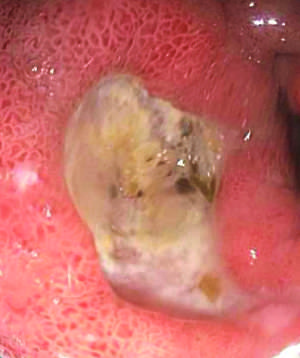s the antral ulcer associated with nsaid use?
Answer the question using a single word or phrase. Yes 